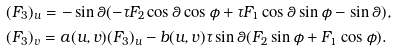Convert formula to latex. <formula><loc_0><loc_0><loc_500><loc_500>& ( F _ { 3 } ) _ { u } = - \sin \theta ( - \tau F _ { 2 } \cos \theta \cos \phi + \tau F _ { 1 } \cos \theta \sin \phi - \sin \theta ) , \\ & ( F _ { 3 } ) _ { v } = a ( u , v ) ( F _ { 3 } ) _ { u } - b ( u , v ) \tau \sin \theta ( F _ { 2 } \sin \phi + F _ { 1 } \cos \phi ) .</formula> 